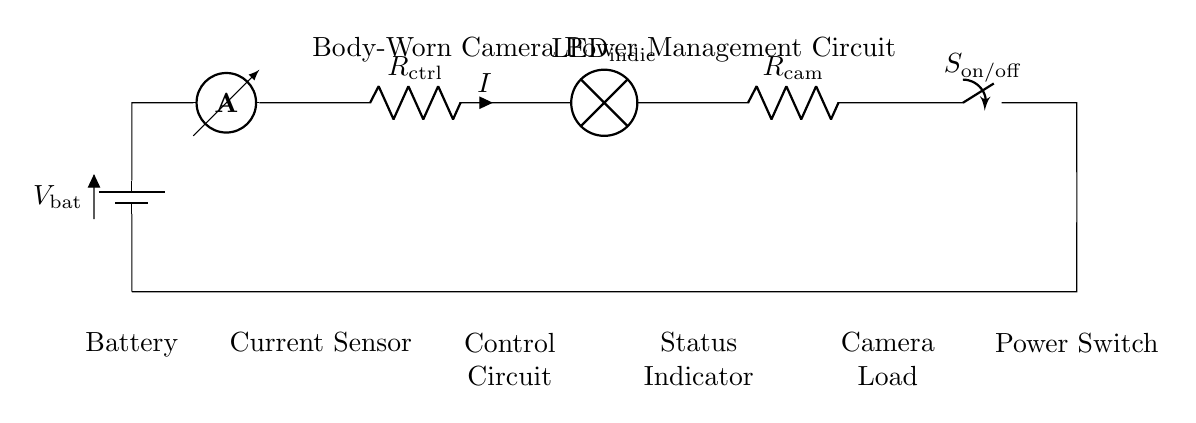What is the power source in this circuit? The power source is represented by the battery symbol labeled as V_bat. It provides the necessary electrical energy for the circuit to function.
Answer: Battery Which component acts as a current measurement device? The current sensor symbol is illustrated in the circuit and is labeled as an ammeter. It measures the current flowing through the circuit.
Answer: Ammeter What type of circuit is depicted in the diagram? The circuit diagram shows a series circuit, as indicated by the connections where all components are arranged in a single pathway for current flow.
Answer: Series How many resistors are present in the circuit? There are two resistors identified in the circuit: R_ctrl and R_cam. The count of these components shows how they influence the current within the circuit.
Answer: Two What is the role of the switch in this circuit? The switch, labeled as S_on/off, controls the flow of electrical current, allowing the user to turn the camera on or off as needed.
Answer: Power control What components are connected directly after the current sensor? After the ammeter, the circuit connects directly to the control circuit, labeled as R_ctrl, which suggests that it manages the flow of current to subsequent devices.
Answer: Control circuit What is indicated by the LED in the circuit? The LED, labeled as LED_indic, serves as a status indicator, showing whether the circuit is powered and functioning properly, typically lighting up when active.
Answer: Status indicator 